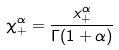<formula> <loc_0><loc_0><loc_500><loc_500>\chi _ { + } ^ { \alpha } = \frac { x _ { + } ^ { \alpha } } { \Gamma ( 1 + \alpha ) }</formula> 